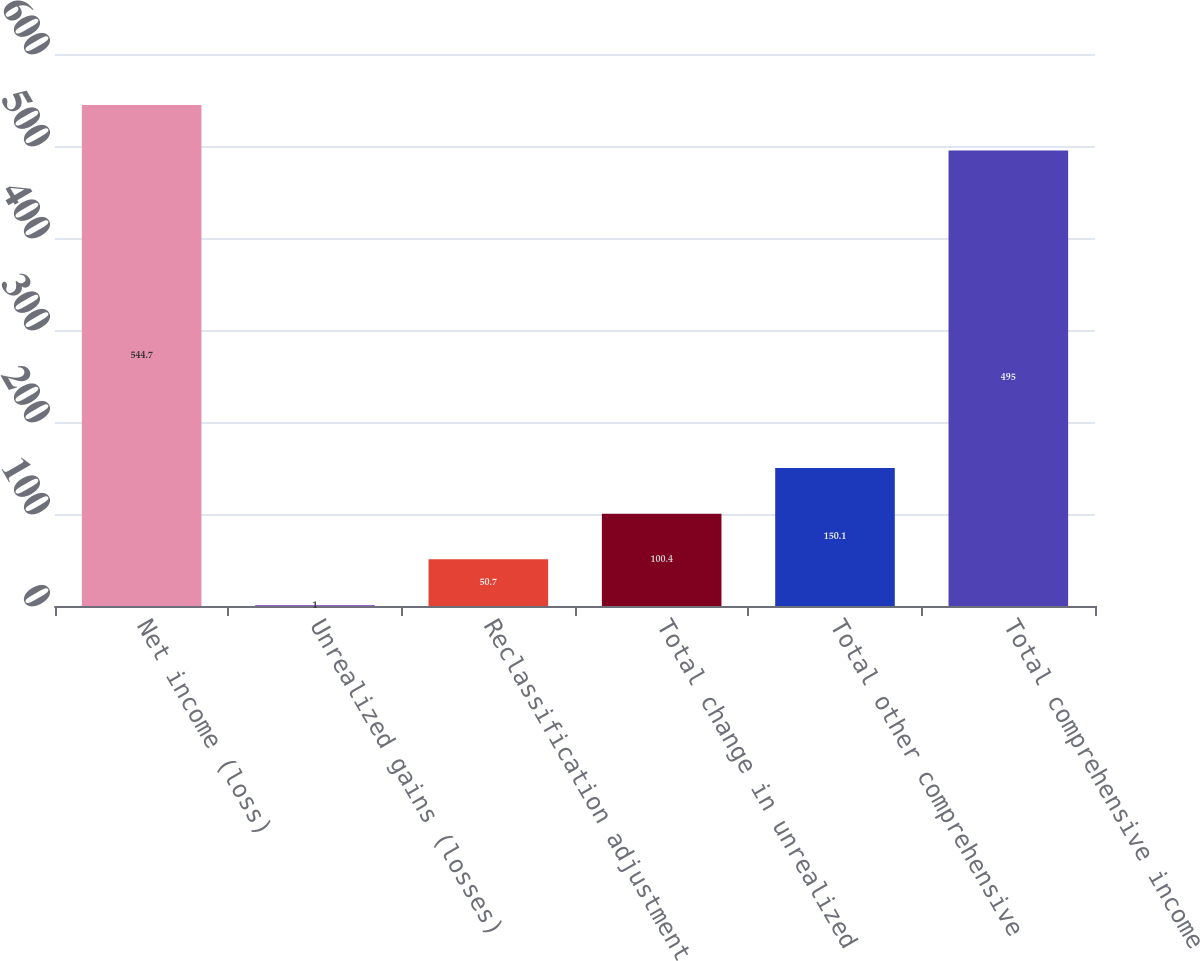Convert chart. <chart><loc_0><loc_0><loc_500><loc_500><bar_chart><fcel>Net income (loss)<fcel>Unrealized gains (losses)<fcel>Reclassification adjustment<fcel>Total change in unrealized<fcel>Total other comprehensive<fcel>Total comprehensive income<nl><fcel>544.7<fcel>1<fcel>50.7<fcel>100.4<fcel>150.1<fcel>495<nl></chart> 